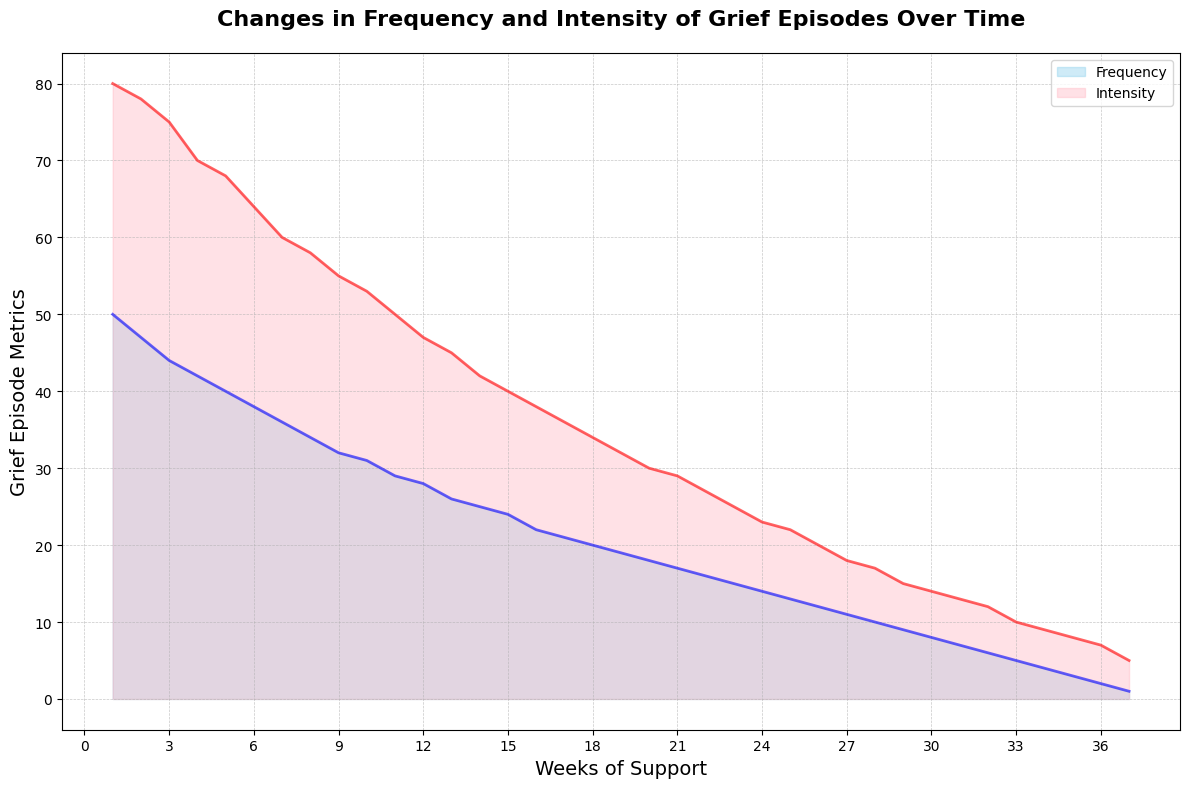What is the general trend in the frequency of grief episodes over the weeks of support? The plot shows a declining trend in the frequency of grief episodes over time. Initially, the frequency is high, but it consistently decreases as the weeks of support progress.
Answer: Declining How does the intensity of grief episodes change from Week 1 to Week 20? The intensity of grief episodes starts at a high value and gradually decreases over time. Initially, it is at 80, and by Week 20, it drops to 30.
Answer: Decreases from 80 to 30 Which week shows the maximum difference between Grief Episode Frequency and Intensity? By reviewing the visual representation, it appears that Week 1 has the most significant difference between the frequency (50) and intensity (80), making the difference = 80 - 50 = 30.
Answer: Week 1 Are there any weeks where Grief Episode Frequency is equal to Grief Episode Intensity? The lines for frequency and intensity do not intersect at any point in the plot, indicating that the frequency is never equal to the intensity in any given week.
Answer: No During which week did both Grief Episode Frequency and Intensity see the steepest decline? By observing the slopes of the lines, the week with the steepest decline appears to be Week 1 to Week 2, where frequency drops from 50 to 47 and intensity drops from 80 to 78.
Answer: Week 1 to Week 2 On average, how much does the Grief Episode Frequency decrease each week? The initial frequency is 50 at Week 1 and drops to 1 by Week 37. The total decrease is 50 - 1 = 49. Dividing this by the number of weeks 37 gives approximately 49/37 ≈ 1.32 units per week.
Answer: 1.32 units per week What are the visual differences between how frequency and intensity are represented in the chart? The frequency area is colored sky blue with a blue line, and the intensity area is colored light pink with a red line. Both use different shades to differentiate the two metrics visually.
Answer: Sky blue and light pink areas with blue and red lines Which point marks the lowest intensity of grief episodes? The lowest point on the intensity line is at Week 37, where the intensity value is marked as 5.
Answer: Week 37 By how much did the intensity of grief episodes decrease between Week 5 and Week 10? At Week 5, the intensity is 68 and at Week 10 it is 53. Thus the decrease is 68 - 53 = 15.
Answer: 15 units Compare the frequency values at Week 10 and Week 20; which one is higher? At Week 10, the frequency is 31, and at Week 20, it is 18. Since 31 is greater than 18, Week 10 has a higher frequency.
Answer: Week 10 